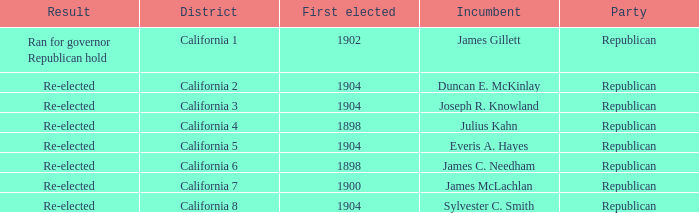Which District has a Result of Re-elected and a First Elected of 1898? California 4, California 6. 